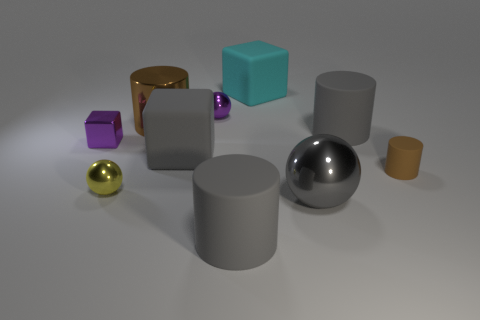Subtract all tiny brown cylinders. How many cylinders are left? 3 Subtract all gray balls. How many balls are left? 2 Subtract 0 yellow cubes. How many objects are left? 10 Subtract all cubes. How many objects are left? 7 Subtract 1 cylinders. How many cylinders are left? 3 Subtract all red balls. Subtract all cyan blocks. How many balls are left? 3 Subtract all red spheres. How many brown cylinders are left? 2 Subtract all yellow metal cylinders. Subtract all purple metal cubes. How many objects are left? 9 Add 1 gray things. How many gray things are left? 5 Add 10 small green shiny blocks. How many small green shiny blocks exist? 10 